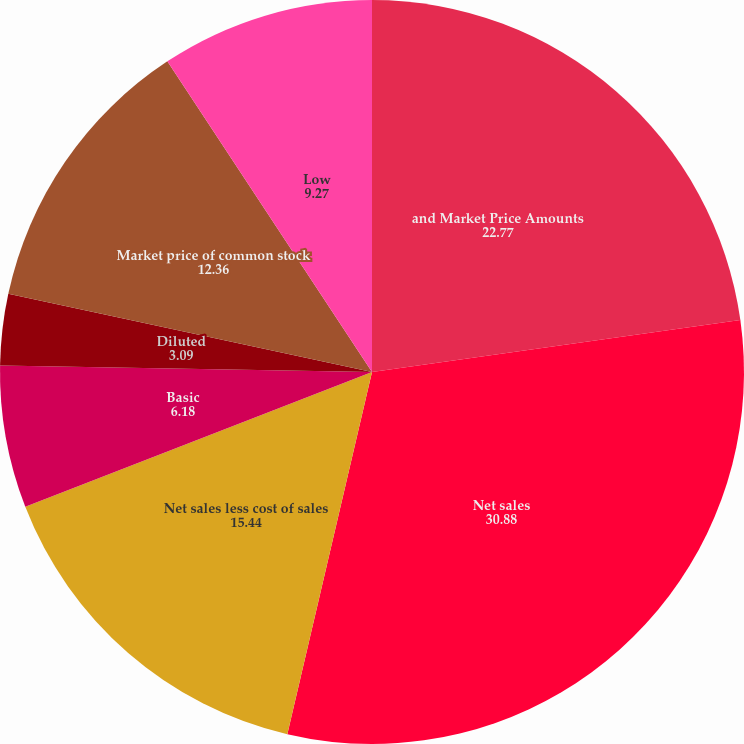Convert chart. <chart><loc_0><loc_0><loc_500><loc_500><pie_chart><fcel>and Market Price Amounts<fcel>Net sales<fcel>Net sales less cost of sales<fcel>Basic<fcel>Diluted<fcel>Dividends per share<fcel>Market price of common stock<fcel>Low<nl><fcel>22.77%<fcel>30.88%<fcel>15.44%<fcel>6.18%<fcel>3.09%<fcel>0.0%<fcel>12.36%<fcel>9.27%<nl></chart> 